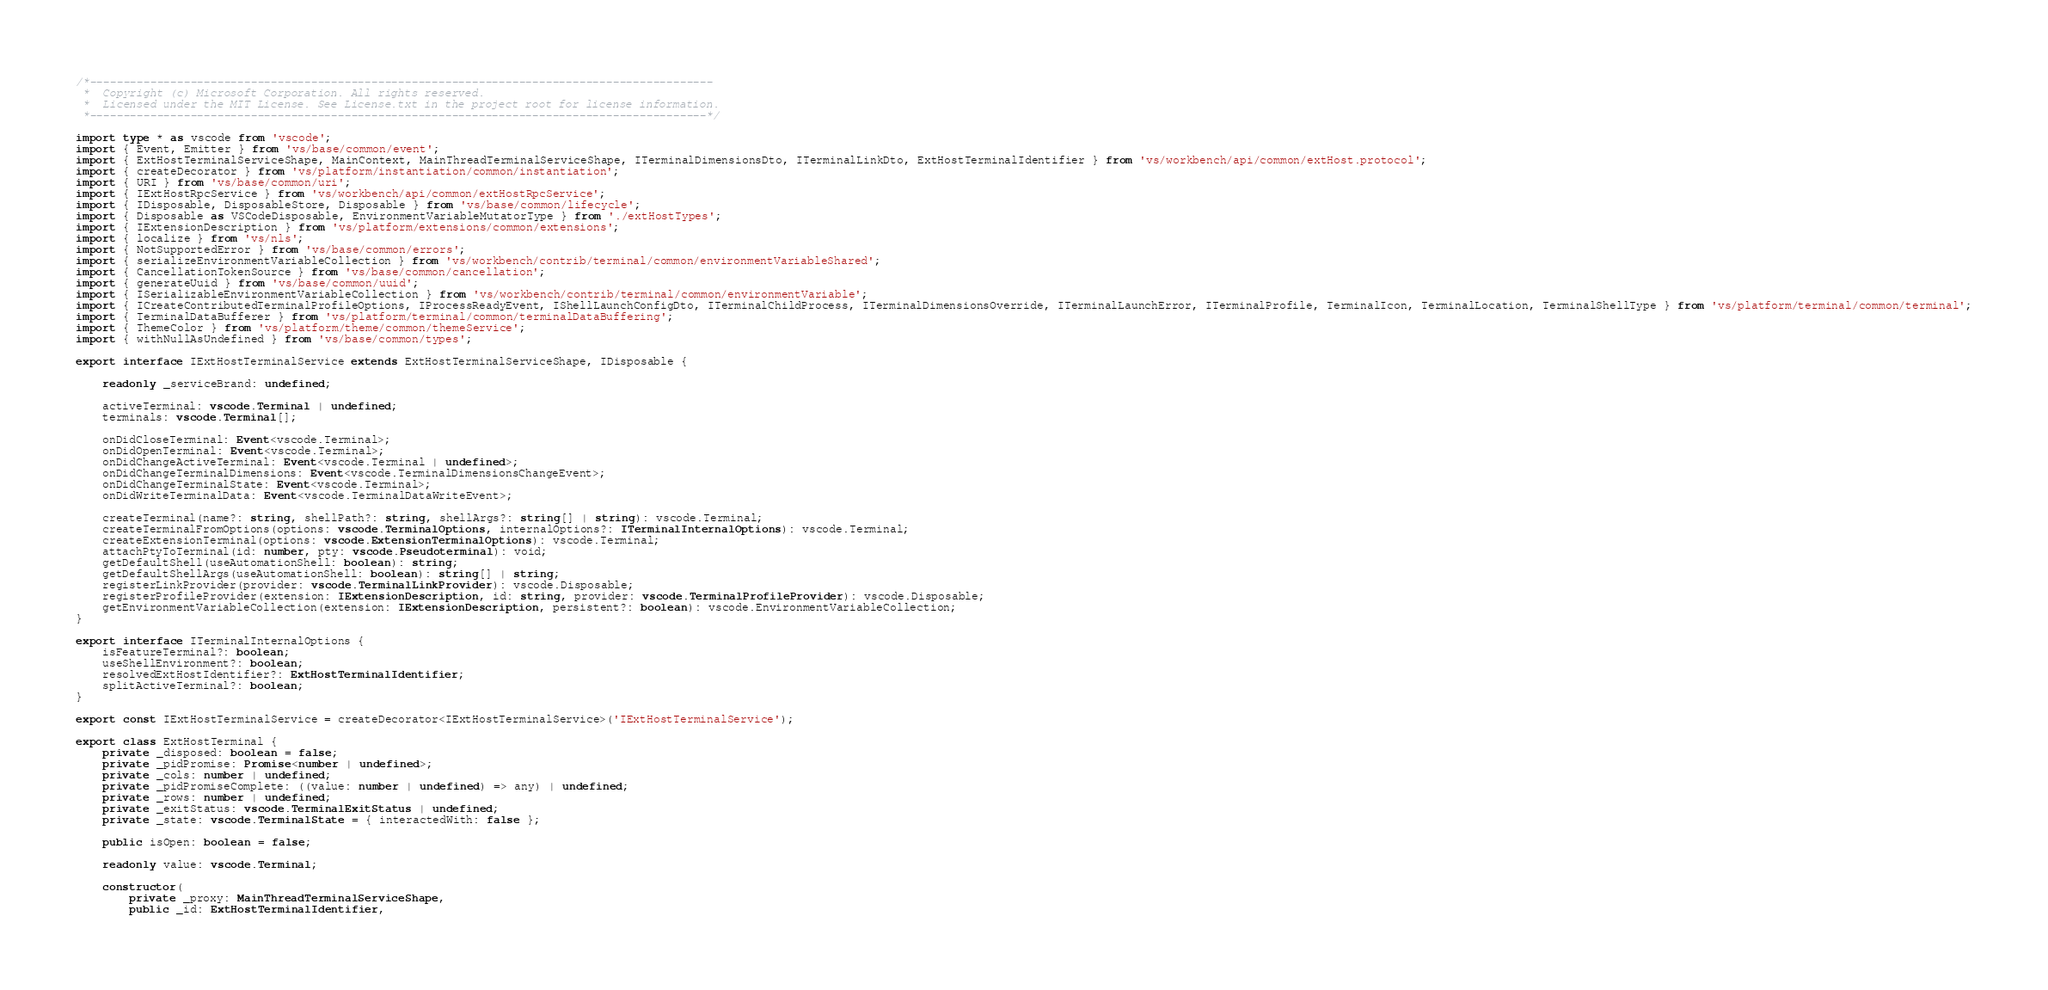Convert code to text. <code><loc_0><loc_0><loc_500><loc_500><_TypeScript_>/*---------------------------------------------------------------------------------------------
 *  Copyright (c) Microsoft Corporation. All rights reserved.
 *  Licensed under the MIT License. See License.txt in the project root for license information.
 *--------------------------------------------------------------------------------------------*/

import type * as vscode from 'vscode';
import { Event, Emitter } from 'vs/base/common/event';
import { ExtHostTerminalServiceShape, MainContext, MainThreadTerminalServiceShape, ITerminalDimensionsDto, ITerminalLinkDto, ExtHostTerminalIdentifier } from 'vs/workbench/api/common/extHost.protocol';
import { createDecorator } from 'vs/platform/instantiation/common/instantiation';
import { URI } from 'vs/base/common/uri';
import { IExtHostRpcService } from 'vs/workbench/api/common/extHostRpcService';
import { IDisposable, DisposableStore, Disposable } from 'vs/base/common/lifecycle';
import { Disposable as VSCodeDisposable, EnvironmentVariableMutatorType } from './extHostTypes';
import { IExtensionDescription } from 'vs/platform/extensions/common/extensions';
import { localize } from 'vs/nls';
import { NotSupportedError } from 'vs/base/common/errors';
import { serializeEnvironmentVariableCollection } from 'vs/workbench/contrib/terminal/common/environmentVariableShared';
import { CancellationTokenSource } from 'vs/base/common/cancellation';
import { generateUuid } from 'vs/base/common/uuid';
import { ISerializableEnvironmentVariableCollection } from 'vs/workbench/contrib/terminal/common/environmentVariable';
import { ICreateContributedTerminalProfileOptions, IProcessReadyEvent, IShellLaunchConfigDto, ITerminalChildProcess, ITerminalDimensionsOverride, ITerminalLaunchError, ITerminalProfile, TerminalIcon, TerminalLocation, TerminalShellType } from 'vs/platform/terminal/common/terminal';
import { TerminalDataBufferer } from 'vs/platform/terminal/common/terminalDataBuffering';
import { ThemeColor } from 'vs/platform/theme/common/themeService';
import { withNullAsUndefined } from 'vs/base/common/types';

export interface IExtHostTerminalService extends ExtHostTerminalServiceShape, IDisposable {

	readonly _serviceBrand: undefined;

	activeTerminal: vscode.Terminal | undefined;
	terminals: vscode.Terminal[];

	onDidCloseTerminal: Event<vscode.Terminal>;
	onDidOpenTerminal: Event<vscode.Terminal>;
	onDidChangeActiveTerminal: Event<vscode.Terminal | undefined>;
	onDidChangeTerminalDimensions: Event<vscode.TerminalDimensionsChangeEvent>;
	onDidChangeTerminalState: Event<vscode.Terminal>;
	onDidWriteTerminalData: Event<vscode.TerminalDataWriteEvent>;

	createTerminal(name?: string, shellPath?: string, shellArgs?: string[] | string): vscode.Terminal;
	createTerminalFromOptions(options: vscode.TerminalOptions, internalOptions?: ITerminalInternalOptions): vscode.Terminal;
	createExtensionTerminal(options: vscode.ExtensionTerminalOptions): vscode.Terminal;
	attachPtyToTerminal(id: number, pty: vscode.Pseudoterminal): void;
	getDefaultShell(useAutomationShell: boolean): string;
	getDefaultShellArgs(useAutomationShell: boolean): string[] | string;
	registerLinkProvider(provider: vscode.TerminalLinkProvider): vscode.Disposable;
	registerProfileProvider(extension: IExtensionDescription, id: string, provider: vscode.TerminalProfileProvider): vscode.Disposable;
	getEnvironmentVariableCollection(extension: IExtensionDescription, persistent?: boolean): vscode.EnvironmentVariableCollection;
}

export interface ITerminalInternalOptions {
	isFeatureTerminal?: boolean;
	useShellEnvironment?: boolean;
	resolvedExtHostIdentifier?: ExtHostTerminalIdentifier;
	splitActiveTerminal?: boolean;
}

export const IExtHostTerminalService = createDecorator<IExtHostTerminalService>('IExtHostTerminalService');

export class ExtHostTerminal {
	private _disposed: boolean = false;
	private _pidPromise: Promise<number | undefined>;
	private _cols: number | undefined;
	private _pidPromiseComplete: ((value: number | undefined) => any) | undefined;
	private _rows: number | undefined;
	private _exitStatus: vscode.TerminalExitStatus | undefined;
	private _state: vscode.TerminalState = { interactedWith: false };

	public isOpen: boolean = false;

	readonly value: vscode.Terminal;

	constructor(
		private _proxy: MainThreadTerminalServiceShape,
		public _id: ExtHostTerminalIdentifier,</code> 